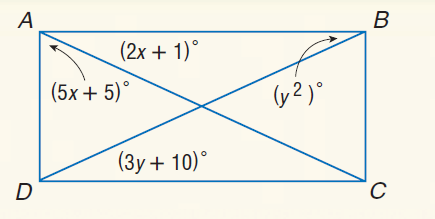Question: Quadrilateral A B C D is a rectangle. Find y.
Choices:
A. 5
B. 12
C. 24
D. 25
Answer with the letter. Answer: A 